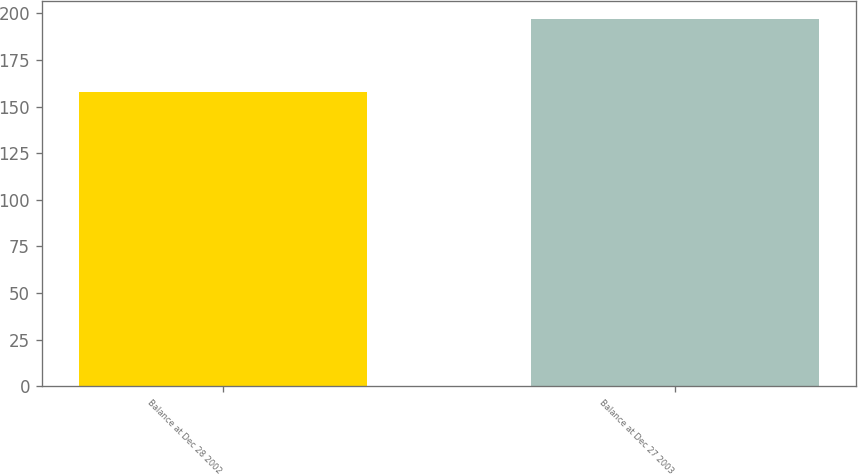Convert chart. <chart><loc_0><loc_0><loc_500><loc_500><bar_chart><fcel>Balance at Dec 28 2002<fcel>Balance at Dec 27 2003<nl><fcel>158<fcel>197<nl></chart> 